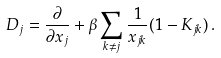Convert formula to latex. <formula><loc_0><loc_0><loc_500><loc_500>D _ { j } = \frac { \partial } { \partial x _ { j } } + \beta \sum _ { k \neq j } \frac { 1 } { x _ { j k } } ( 1 - K _ { j k } ) \, .</formula> 